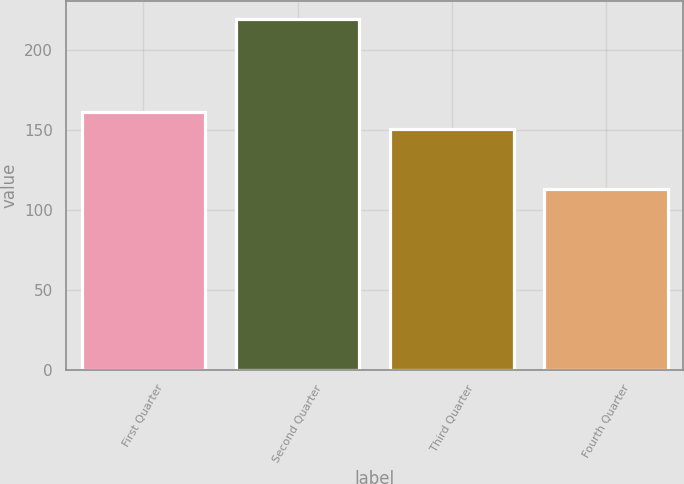Convert chart. <chart><loc_0><loc_0><loc_500><loc_500><bar_chart><fcel>First Quarter<fcel>Second Quarter<fcel>Third Quarter<fcel>Fourth Quarter<nl><fcel>161.28<fcel>219.85<fcel>150.6<fcel>113.05<nl></chart> 